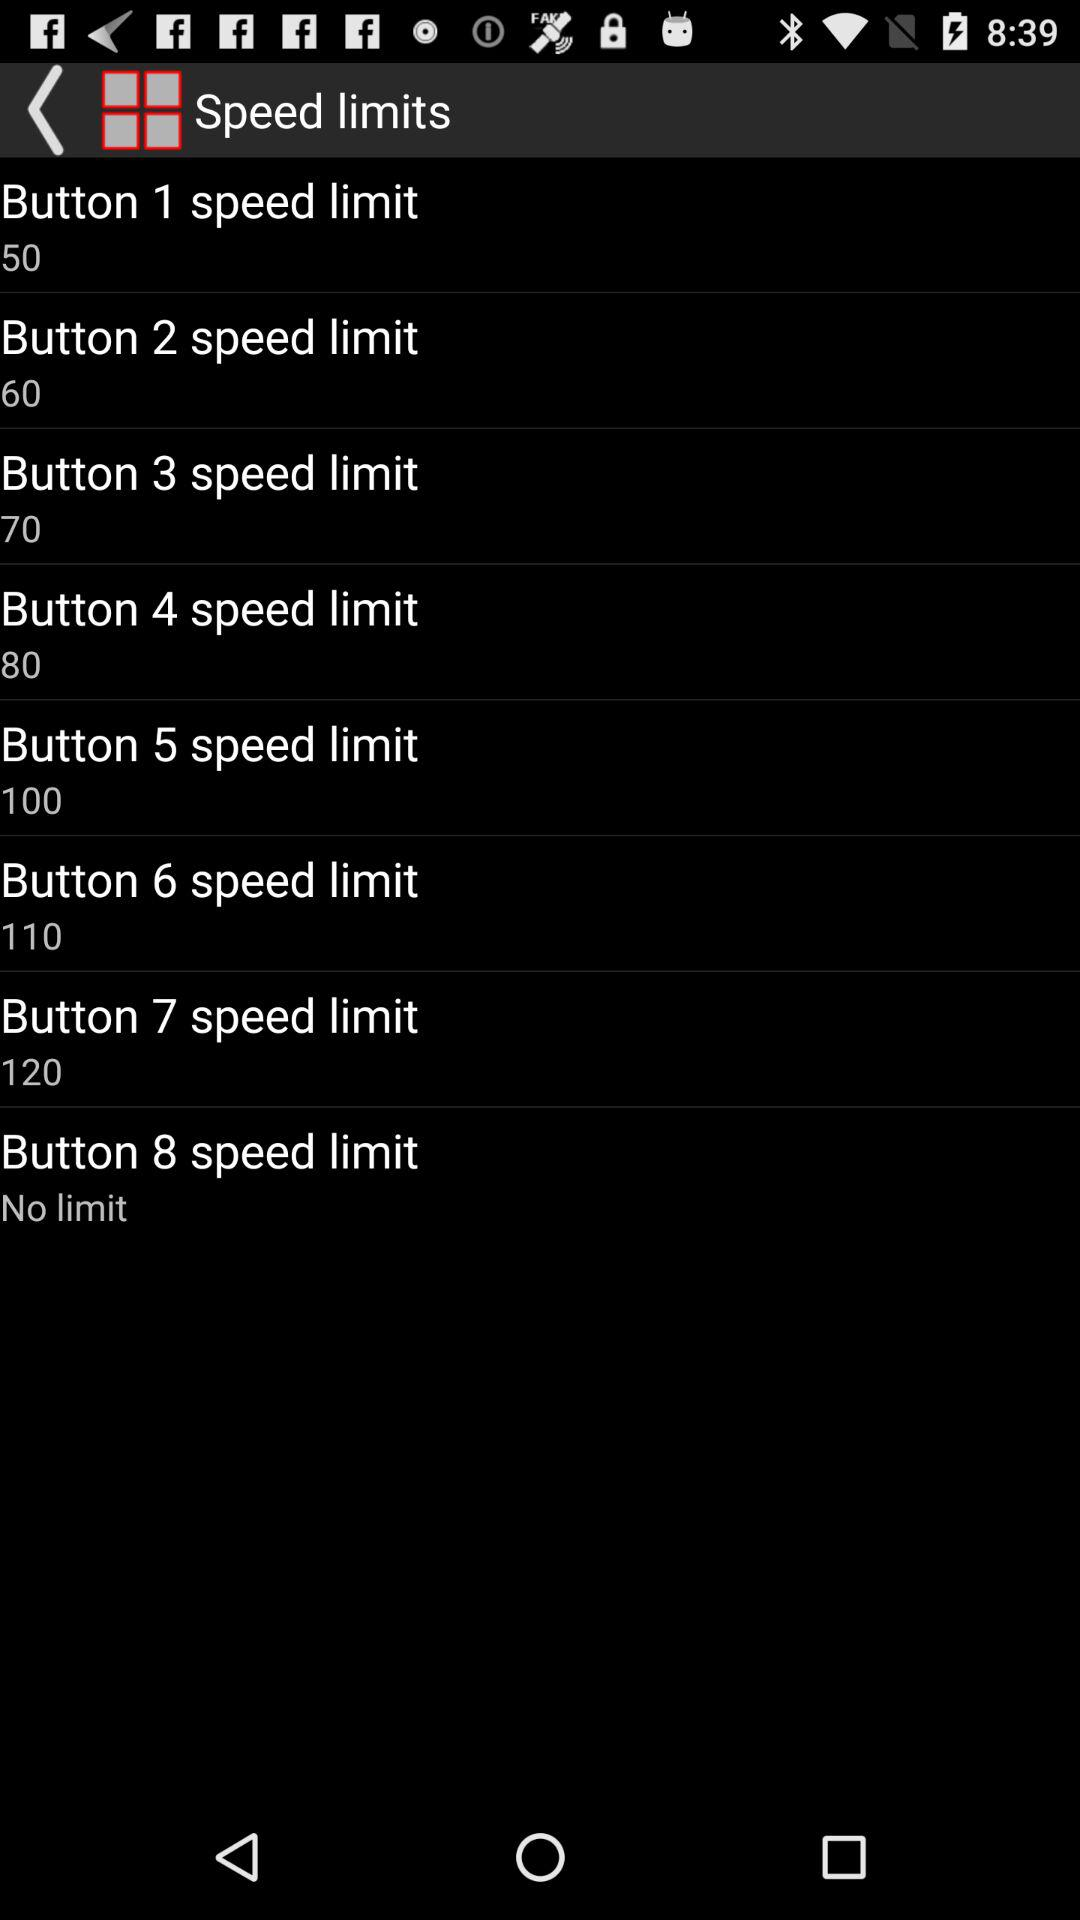Which button has "No limit" for speed? The button is 8. 